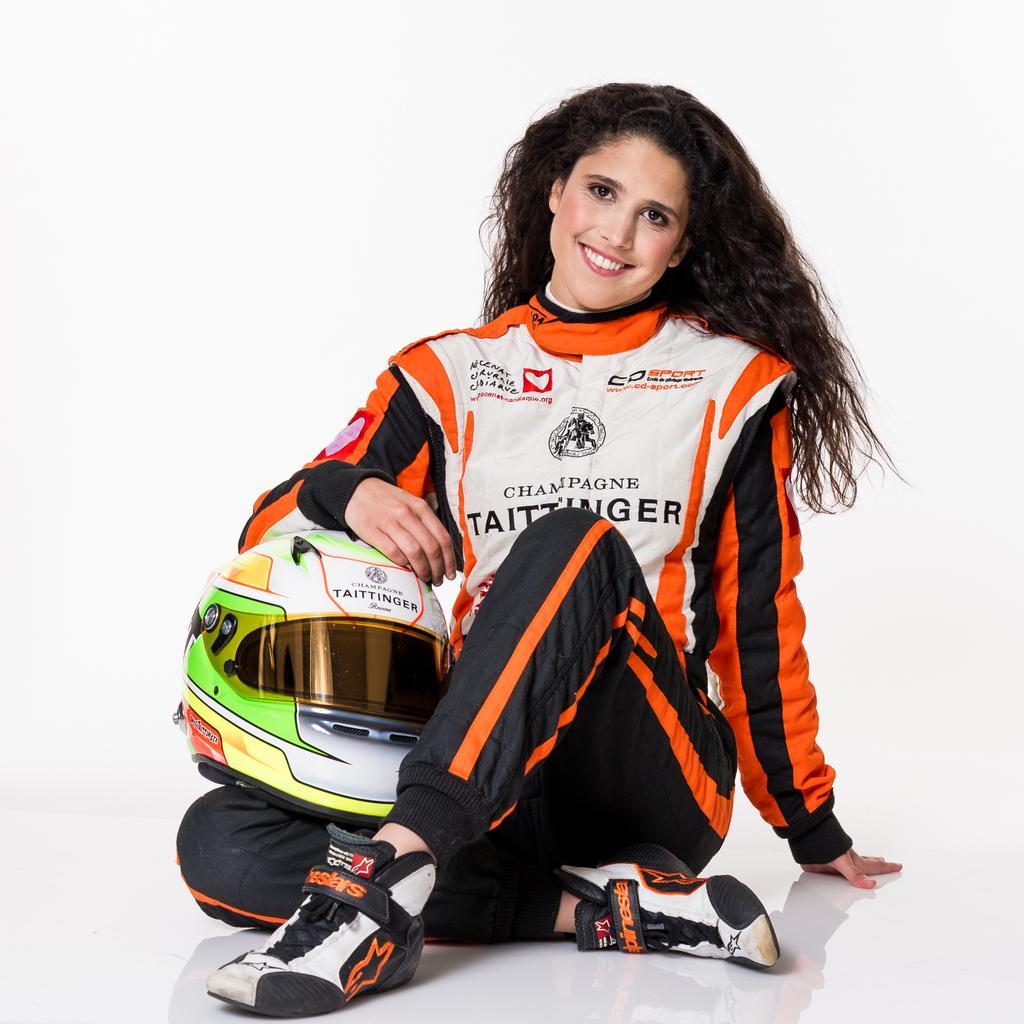In one or two sentences, can you explain what this image depicts? Here I can see a woman wearing a jacket, shoes, holding a helmet in the hand, sitting, smiling and giving pose for the picture. The background is in white color. 